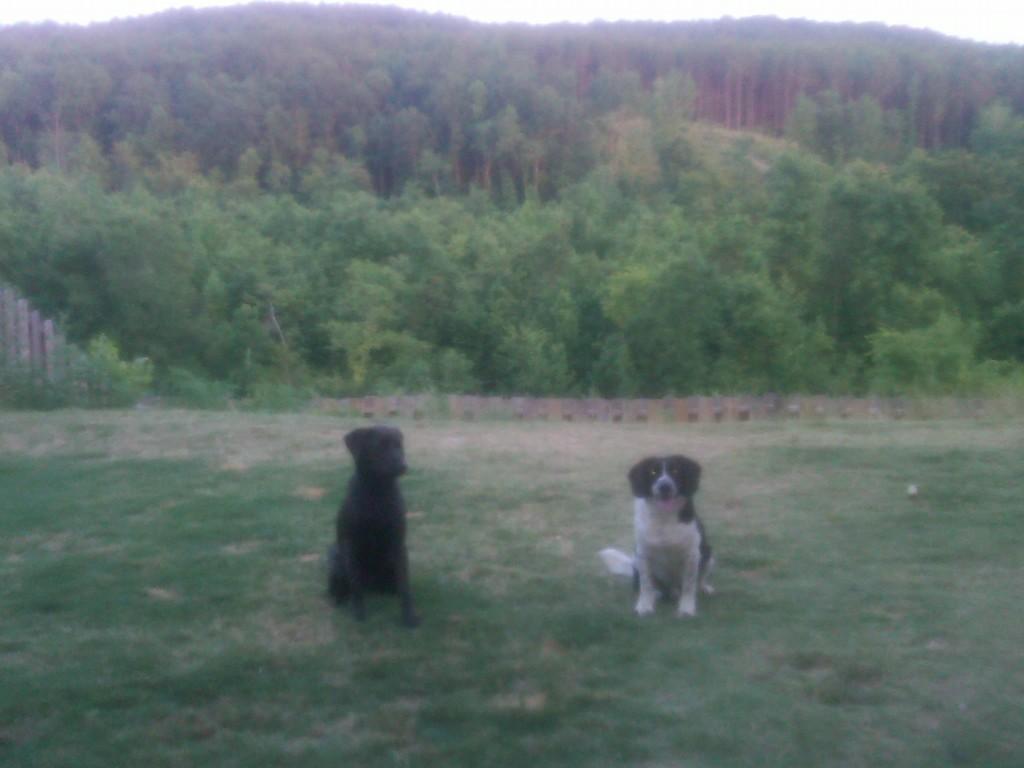Describe this image in one or two sentences. In this image I can see two animals and they are in black and white color. In the background I can see few trees in green color and the sky is in white color. 